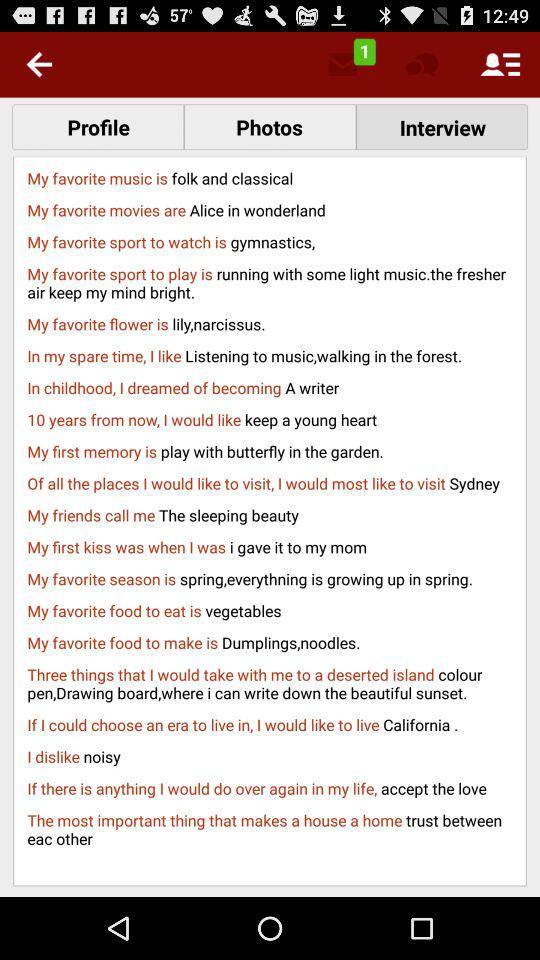Which tab has been selected? The selected tab is "Interview". 